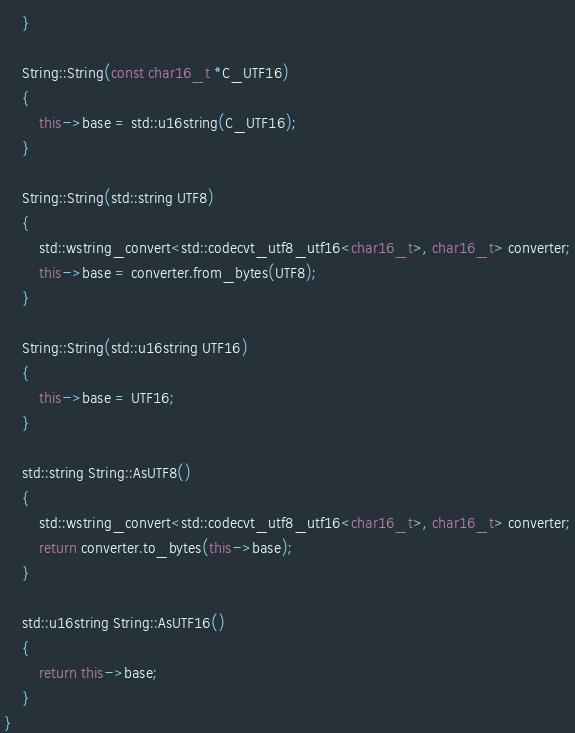Convert code to text. <code><loc_0><loc_0><loc_500><loc_500><_C++_>    }

    String::String(const char16_t *C_UTF16)
    {
        this->base = std::u16string(C_UTF16);
    }

    String::String(std::string UTF8)
    {
        std::wstring_convert<std::codecvt_utf8_utf16<char16_t>, char16_t> converter;
        this->base = converter.from_bytes(UTF8);
    }

    String::String(std::u16string UTF16)
    {
        this->base = UTF16;
    }

    std::string String::AsUTF8()
    {
        std::wstring_convert<std::codecvt_utf8_utf16<char16_t>, char16_t> converter;
        return converter.to_bytes(this->base);
    }

    std::u16string String::AsUTF16()
    {
        return this->base;
    }
}</code> 